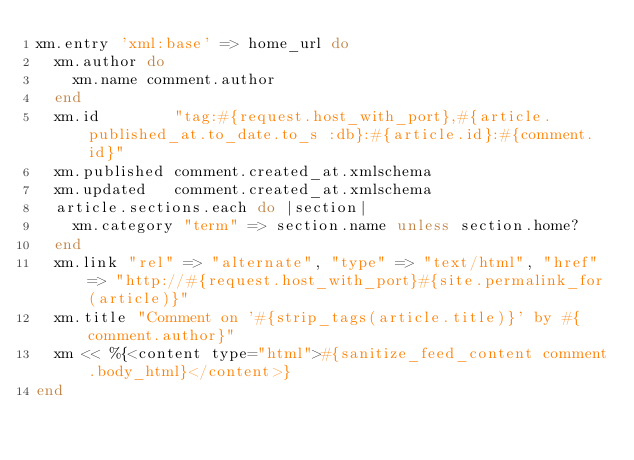<code> <loc_0><loc_0><loc_500><loc_500><_Ruby_>xm.entry 'xml:base' => home_url do
  xm.author do
    xm.name comment.author
  end
  xm.id        "tag:#{request.host_with_port},#{article.published_at.to_date.to_s :db}:#{article.id}:#{comment.id}"
  xm.published comment.created_at.xmlschema
  xm.updated   comment.created_at.xmlschema
  article.sections.each do |section|
    xm.category "term" => section.name unless section.home?
  end
  xm.link "rel" => "alternate", "type" => "text/html", "href" => "http://#{request.host_with_port}#{site.permalink_for(article)}"
  xm.title "Comment on '#{strip_tags(article.title)}' by #{comment.author}"
  xm << %{<content type="html">#{sanitize_feed_content comment.body_html}</content>}
end</code> 